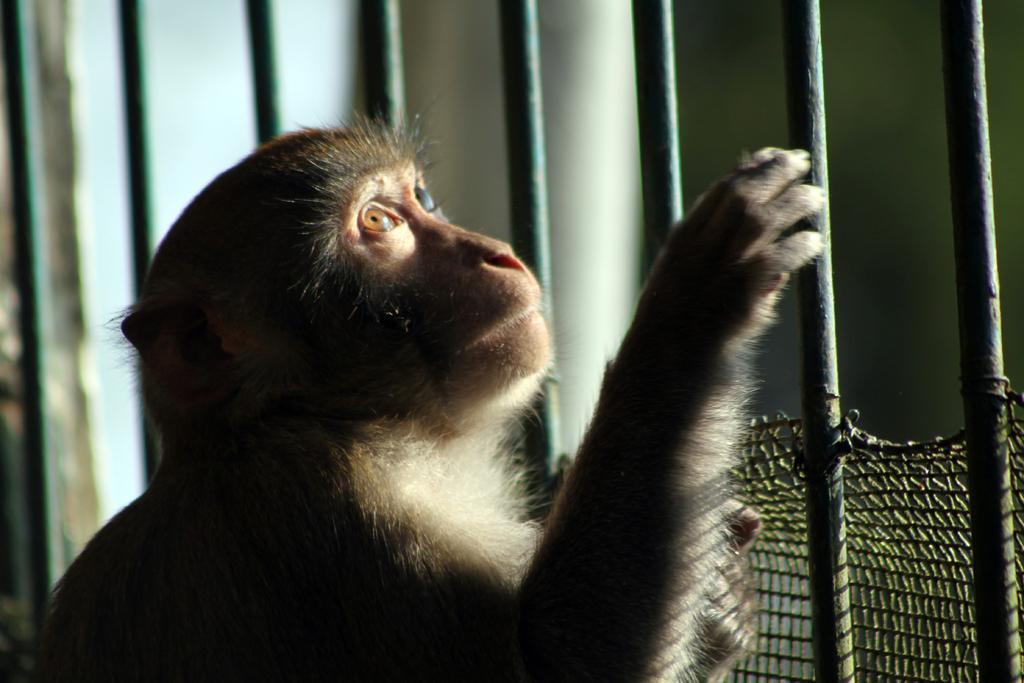Could you give a brief overview of what you see in this image? In the picture we can see a monkey near the railing, looking upwards and to the railing we can see a part of net to it. 